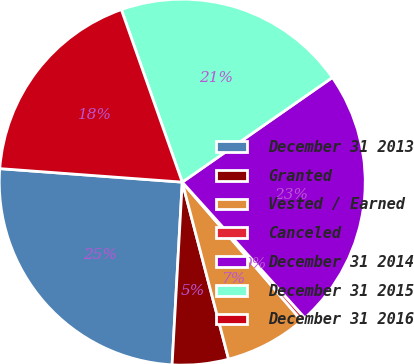Convert chart. <chart><loc_0><loc_0><loc_500><loc_500><pie_chart><fcel>December 31 2013<fcel>Granted<fcel>Vested / Earned<fcel>Canceled<fcel>December 31 2014<fcel>December 31 2015<fcel>December 31 2016<nl><fcel>25.29%<fcel>4.96%<fcel>7.25%<fcel>0.36%<fcel>23.0%<fcel>20.71%<fcel>18.42%<nl></chart> 